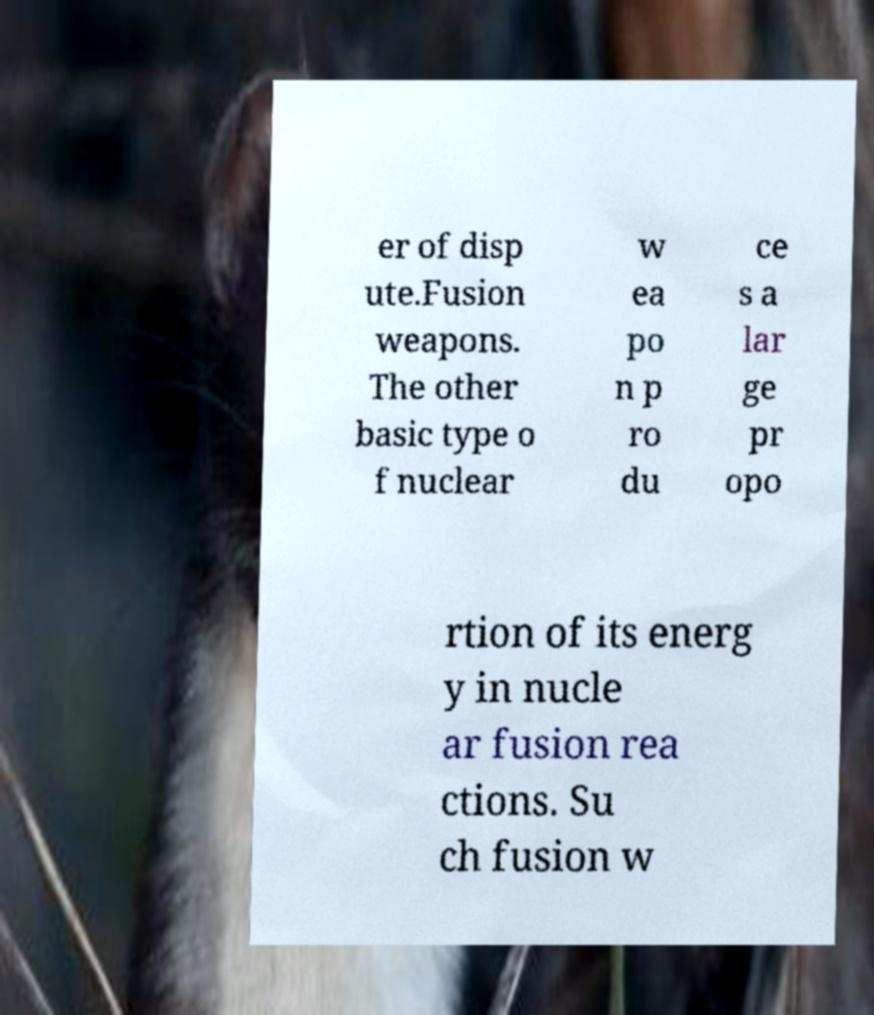Could you extract and type out the text from this image? er of disp ute.Fusion weapons. The other basic type o f nuclear w ea po n p ro du ce s a lar ge pr opo rtion of its energ y in nucle ar fusion rea ctions. Su ch fusion w 